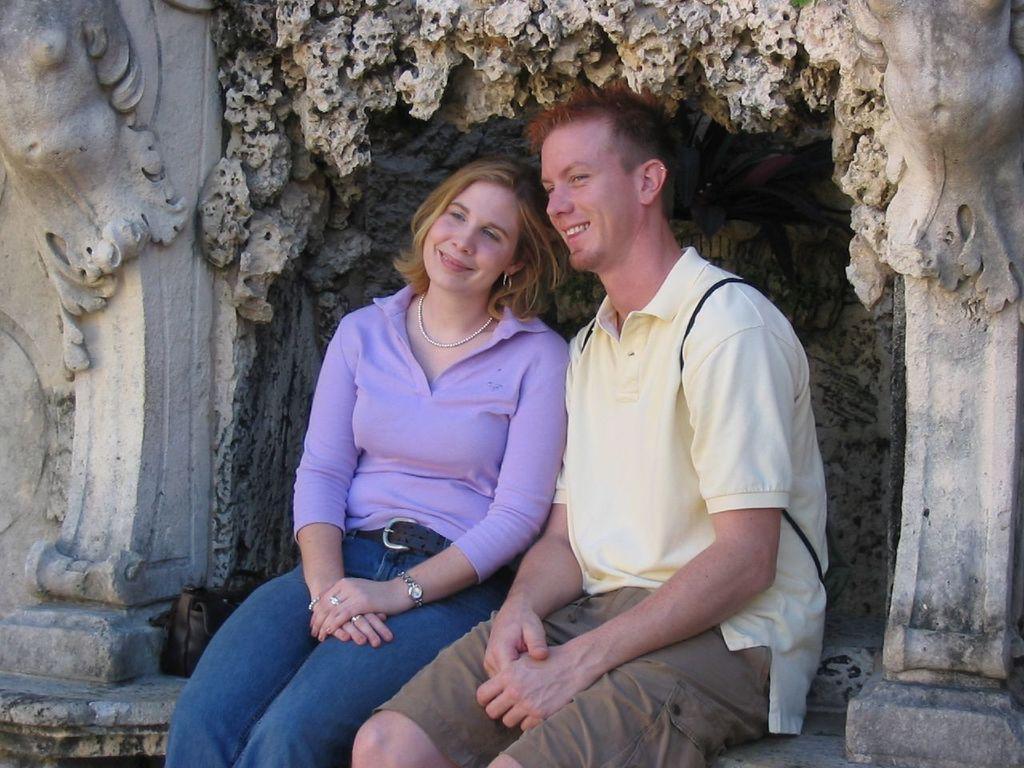In one or two sentences, can you explain what this image depicts? In the image we can see a man and a woman sitting, they are wearing clothes. The woman is wearing a neck chain, earring, wrist watch and finger ring. This is a wall design. 